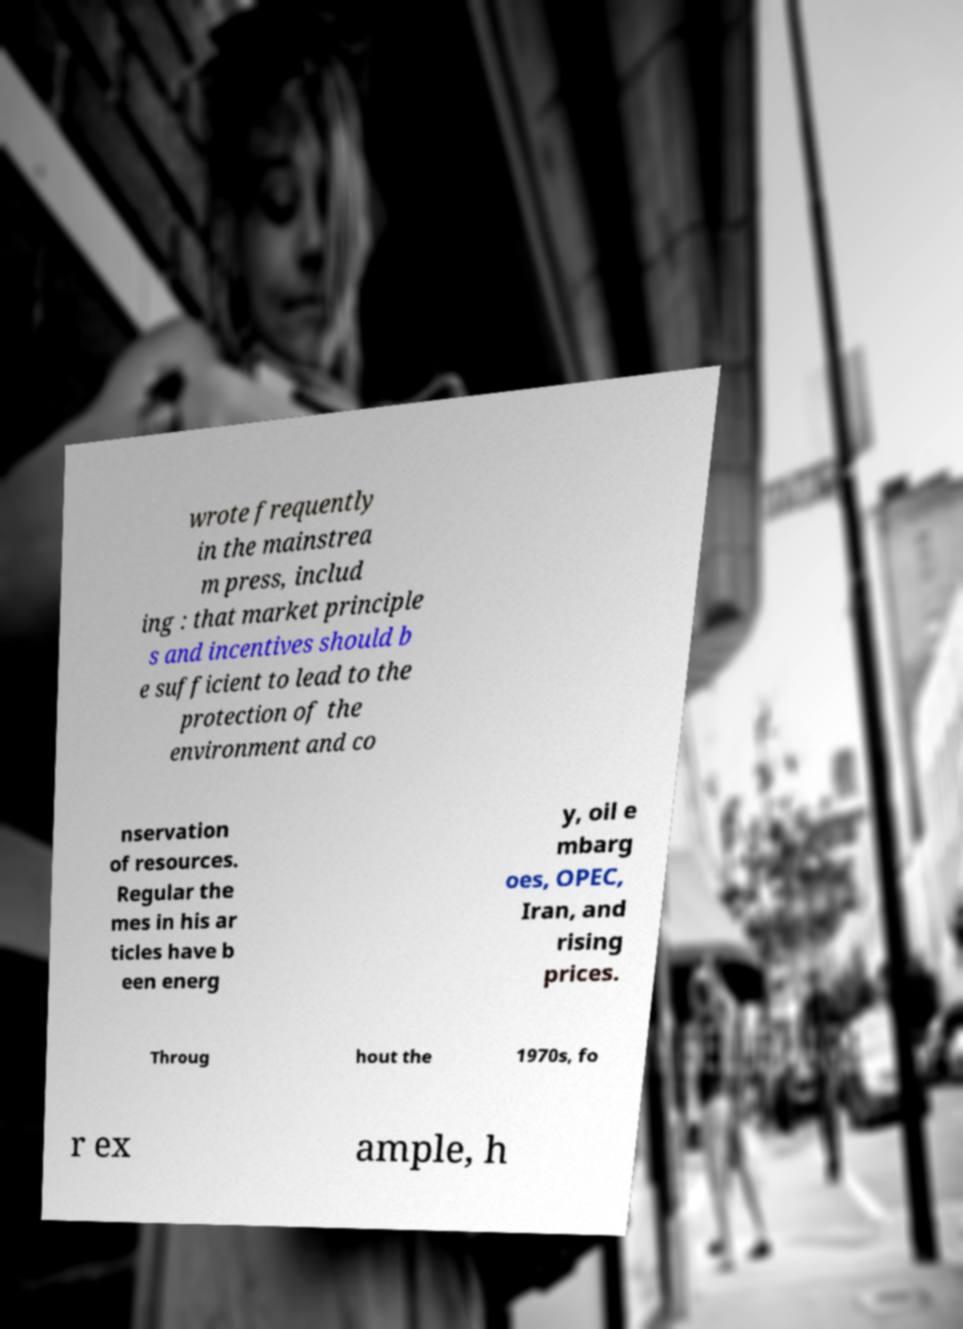I need the written content from this picture converted into text. Can you do that? wrote frequently in the mainstrea m press, includ ing : that market principle s and incentives should b e sufficient to lead to the protection of the environment and co nservation of resources. Regular the mes in his ar ticles have b een energ y, oil e mbarg oes, OPEC, Iran, and rising prices. Throug hout the 1970s, fo r ex ample, h 